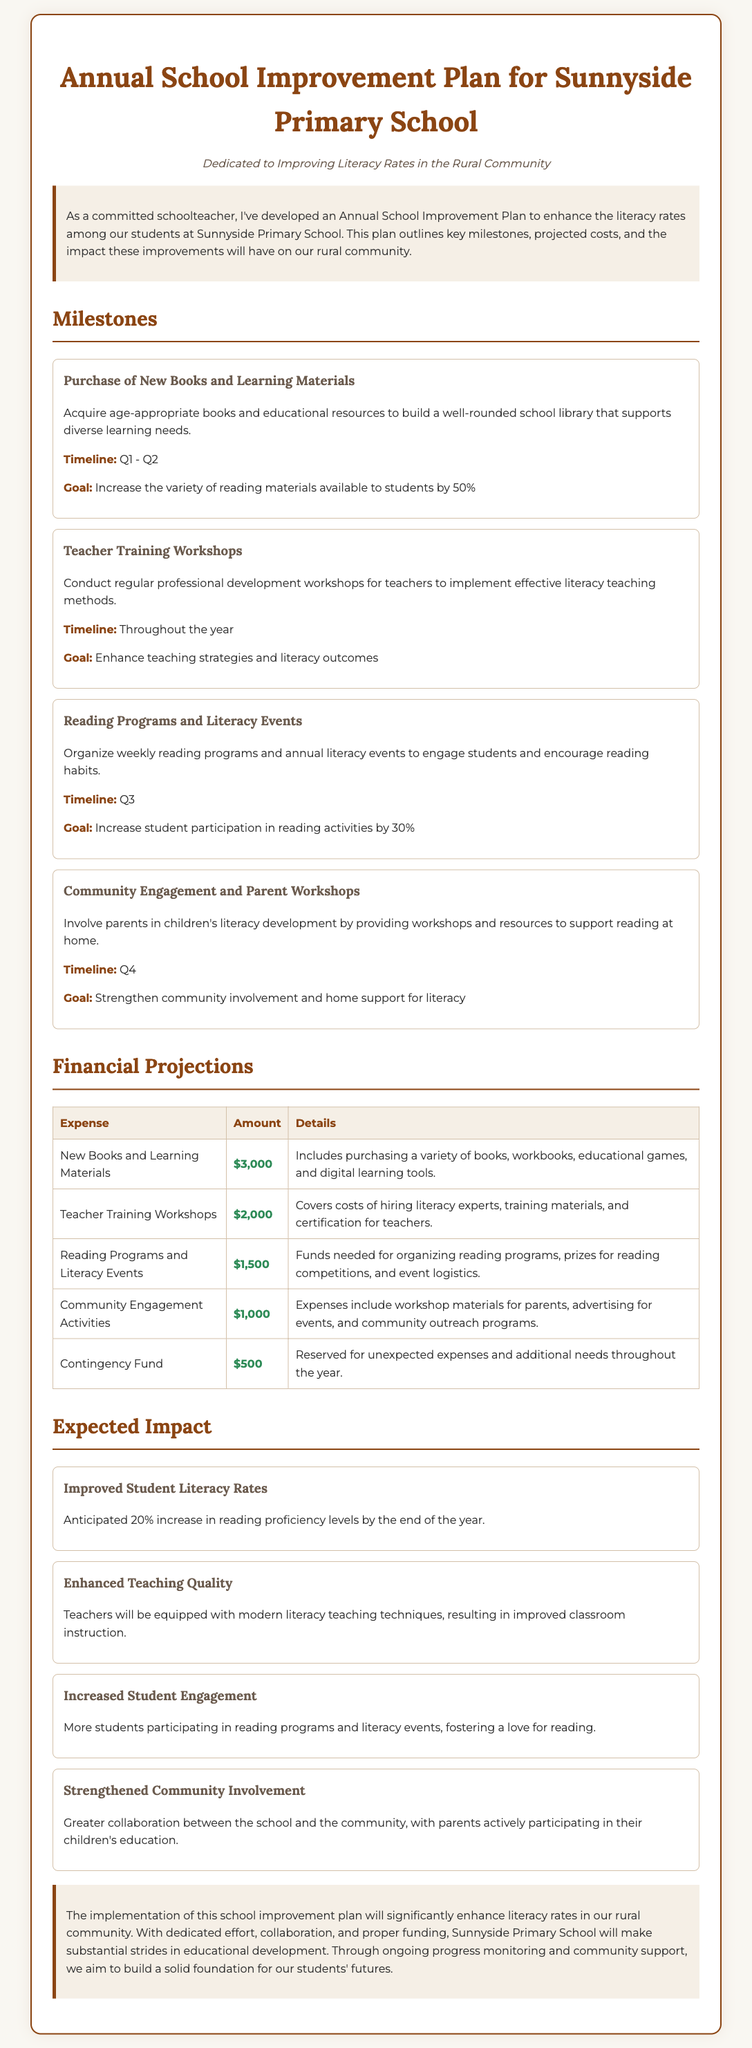what is the total budget for new books and learning materials? The budget for new books and learning materials is listed in the financial projections section of the document as $3,000.
Answer: $3,000 what is the goal for the reading programs and literacy events? The goal for the reading programs and literacy events is to increase student participation in reading activities by 30%.
Answer: Increase student participation in reading activities by 30% how much is allocated for contingency fund? The contingency fund amount is detailed in the financial projections table, showing that it is $500.
Answer: $500 what is the timeline for community engagement and parent workshops? The timeline for community engagement and parent workshops as mentioned in the milestones section is Q4.
Answer: Q4 what is the expected increase in reading proficiency levels? The expected increase in reading proficiency levels is noted as 20% by the end of the year.
Answer: 20% which milestone involves involving parents in children's literacy development? The milestone that includes involving parents in children's literacy development is titled "Community Engagement and Parent Workshops."
Answer: Community Engagement and Parent Workshops how much is budgeted for teacher training workshops? The amount budgeted for teacher training workshops is included in the financial projections, which specifies $2,000.
Answer: $2,000 what is the anticipated impact on teaching quality? The anticipated impact on teaching quality indicates that teachers will be equipped with modern literacy teaching techniques.
Answer: Teachers will be equipped with modern literacy teaching techniques 